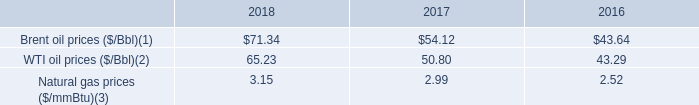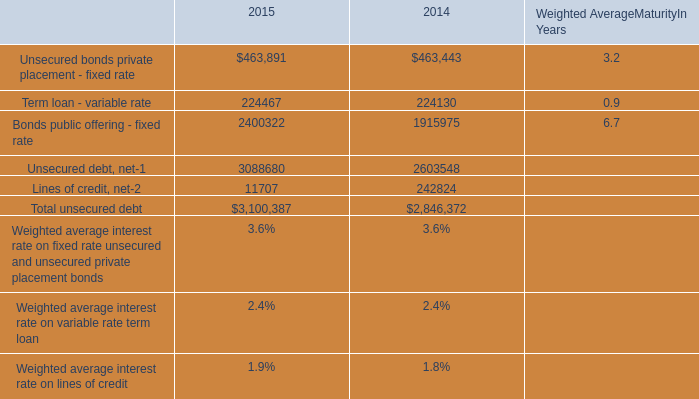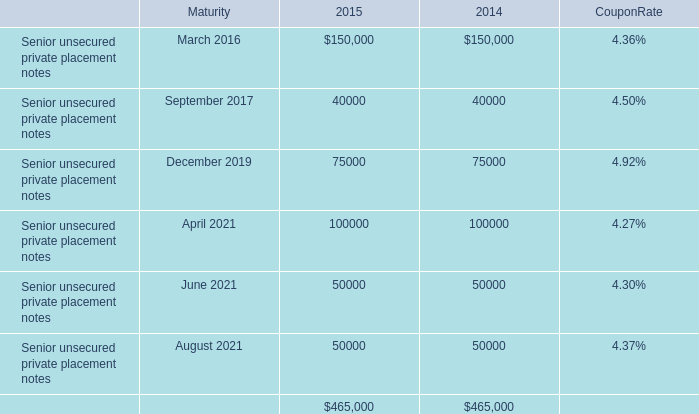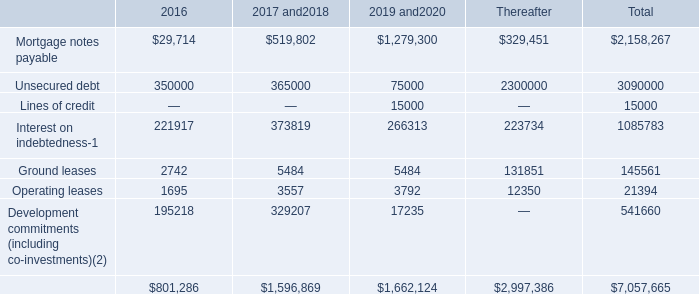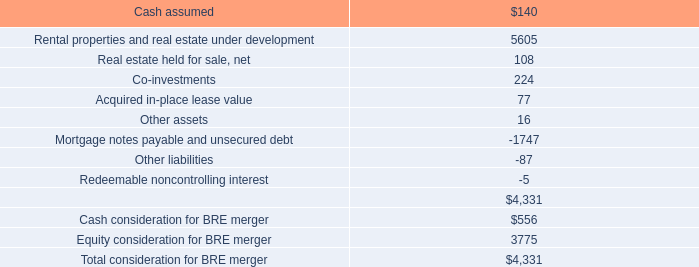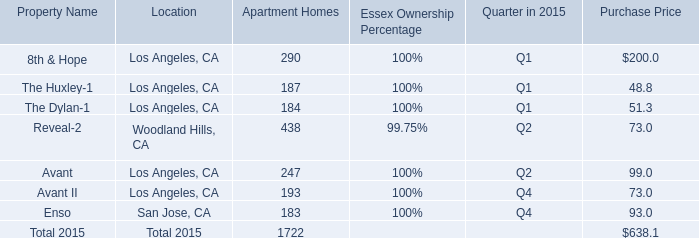What's the total value of all Apartment Homes that are smaller than 400 in 2015? 
Computations: (((((290 + 187) + 184) + 247) + 193) + 183)
Answer: 1284.0. 